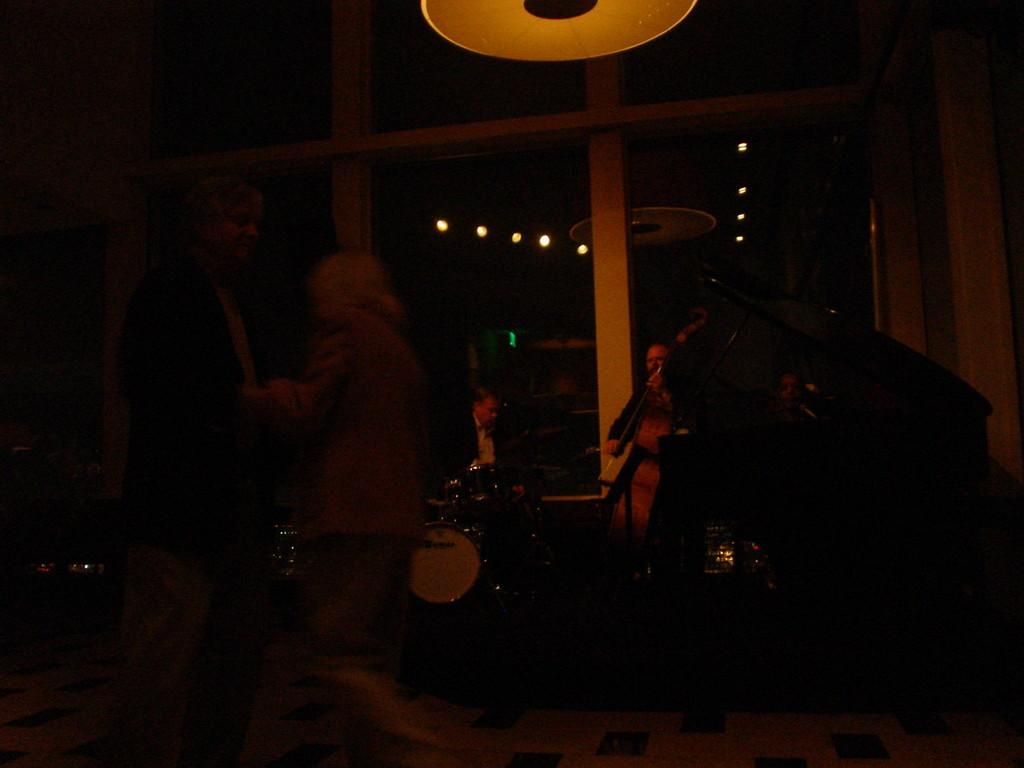Who or what is present in the image? There are people in the image. What are the people doing in the image? The people are playing musical instruments in the image. What else can be seen in the image besides the people and musical instruments? There are lights visible in the image. How would you describe the overall lighting in the image? The image appears to be dark. What letters are being used to spell out a word on the musical instruments in the image? There are no letters visible on the musical instruments in the image. How does the journey of the people in the image relate to the sink in the room? There is no mention of a journey or a sink in the image. 